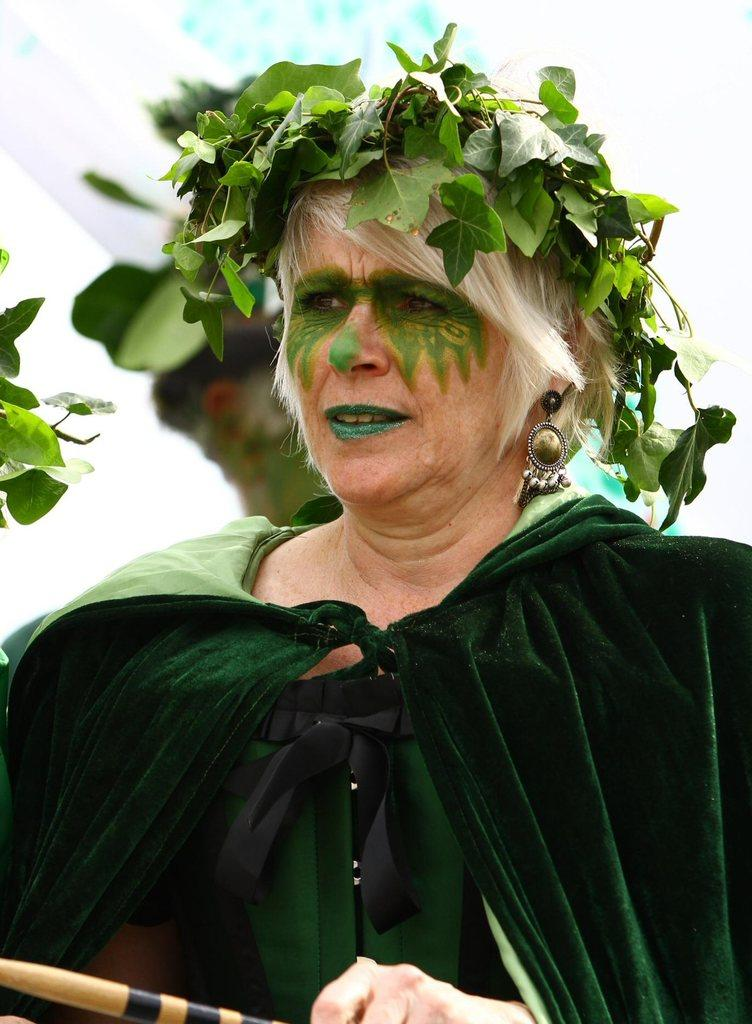Who is the main subject in the image? There is a woman in the image. What is unique about the woman's appearance? The woman has a painted face. What is on the woman's head? There are leaves on the woman's head. How many eggs can be seen in the image? There are no eggs present in the image. What is the size of the club in the image? There is no club present in the image. 